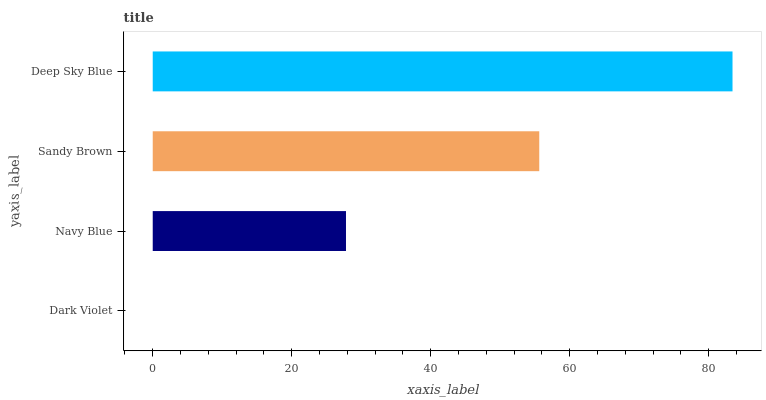Is Dark Violet the minimum?
Answer yes or no. Yes. Is Deep Sky Blue the maximum?
Answer yes or no. Yes. Is Navy Blue the minimum?
Answer yes or no. No. Is Navy Blue the maximum?
Answer yes or no. No. Is Navy Blue greater than Dark Violet?
Answer yes or no. Yes. Is Dark Violet less than Navy Blue?
Answer yes or no. Yes. Is Dark Violet greater than Navy Blue?
Answer yes or no. No. Is Navy Blue less than Dark Violet?
Answer yes or no. No. Is Sandy Brown the high median?
Answer yes or no. Yes. Is Navy Blue the low median?
Answer yes or no. Yes. Is Deep Sky Blue the high median?
Answer yes or no. No. Is Deep Sky Blue the low median?
Answer yes or no. No. 